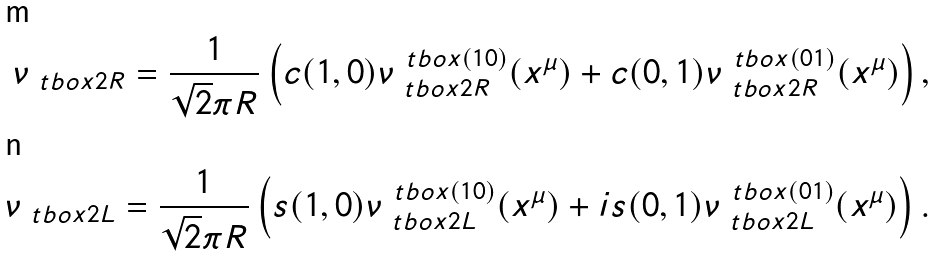Convert formula to latex. <formula><loc_0><loc_0><loc_500><loc_500>\nu _ { \ t b o x { 2 R } } = \frac { 1 } { \sqrt { 2 } \pi R } \left ( c ( 1 , 0 ) \nu ^ { \ t b o x { ( 1 0 ) } } _ { \ t b o x { 2 R } } ( x ^ { \mu } ) + c ( 0 , 1 ) \nu ^ { \ t b o x { ( 0 1 ) } } _ { \ t b o x { 2 R } } ( x ^ { \mu } ) \right ) , \\ \nu _ { \ t b o x { 2 L } } = \frac { 1 } { \sqrt { 2 } \pi R } \left ( s ( 1 , 0 ) \nu ^ { { \ t b o x { ( 1 0 ) } } } _ { \ t b o x { 2 L } } ( x ^ { \mu } ) + i s ( 0 , 1 ) \nu ^ { \ t b o x { ( 0 1 ) } } _ { \ t b o x { 2 L } } ( x ^ { \mu } ) \right ) .</formula> 